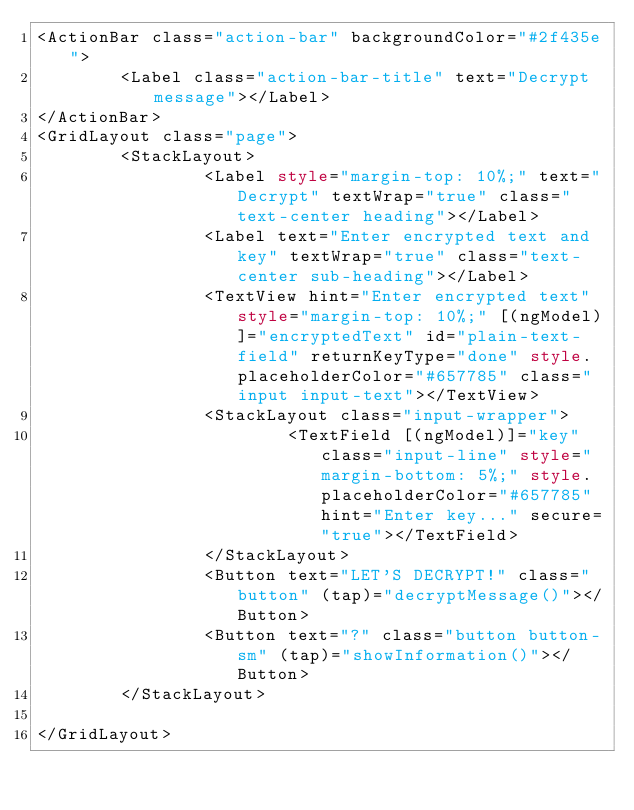<code> <loc_0><loc_0><loc_500><loc_500><_HTML_><ActionBar class="action-bar" backgroundColor="#2f435e">
        <Label class="action-bar-title" text="Decrypt message"></Label>
</ActionBar>
<GridLayout class="page">
        <StackLayout>
                <Label style="margin-top: 10%;" text="Decrypt" textWrap="true" class="text-center heading"></Label>
                <Label text="Enter encrypted text and key" textWrap="true" class="text-center sub-heading"></Label>
                <TextView hint="Enter encrypted text" style="margin-top: 10%;" [(ngModel)]="encryptedText" id="plain-text-field" returnKeyType="done" style.placeholderColor="#657785" class="input input-text"></TextView>
                <StackLayout class="input-wrapper">
                        <TextField [(ngModel)]="key" class="input-line" style="margin-bottom: 5%;" style.placeholderColor="#657785" hint="Enter key..." secure="true"></TextField>
                </StackLayout>
                <Button text="LET'S DECRYPT!" class="button" (tap)="decryptMessage()"></Button>
                <Button text="?" class="button button-sm" (tap)="showInformation()"></Button>
        </StackLayout>
                
</GridLayout></code> 